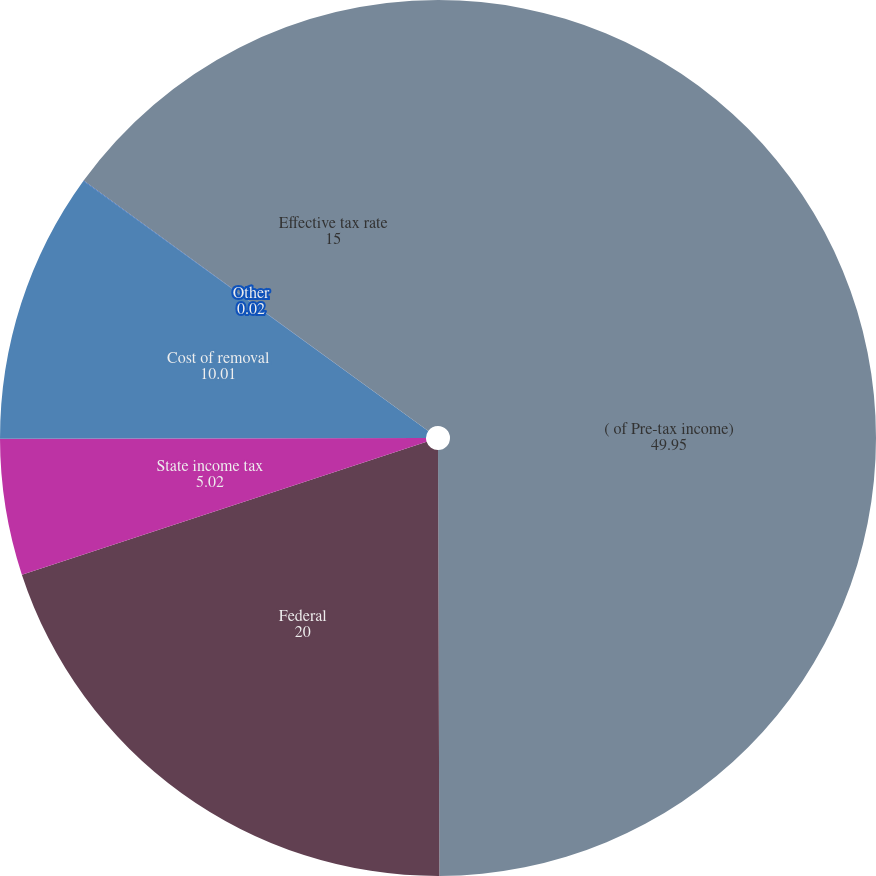Convert chart to OTSL. <chart><loc_0><loc_0><loc_500><loc_500><pie_chart><fcel>( of Pre-tax income)<fcel>Federal<fcel>State income tax<fcel>Cost of removal<fcel>Other<fcel>Effective tax rate<nl><fcel>49.95%<fcel>20.0%<fcel>5.02%<fcel>10.01%<fcel>0.02%<fcel>15.0%<nl></chart> 